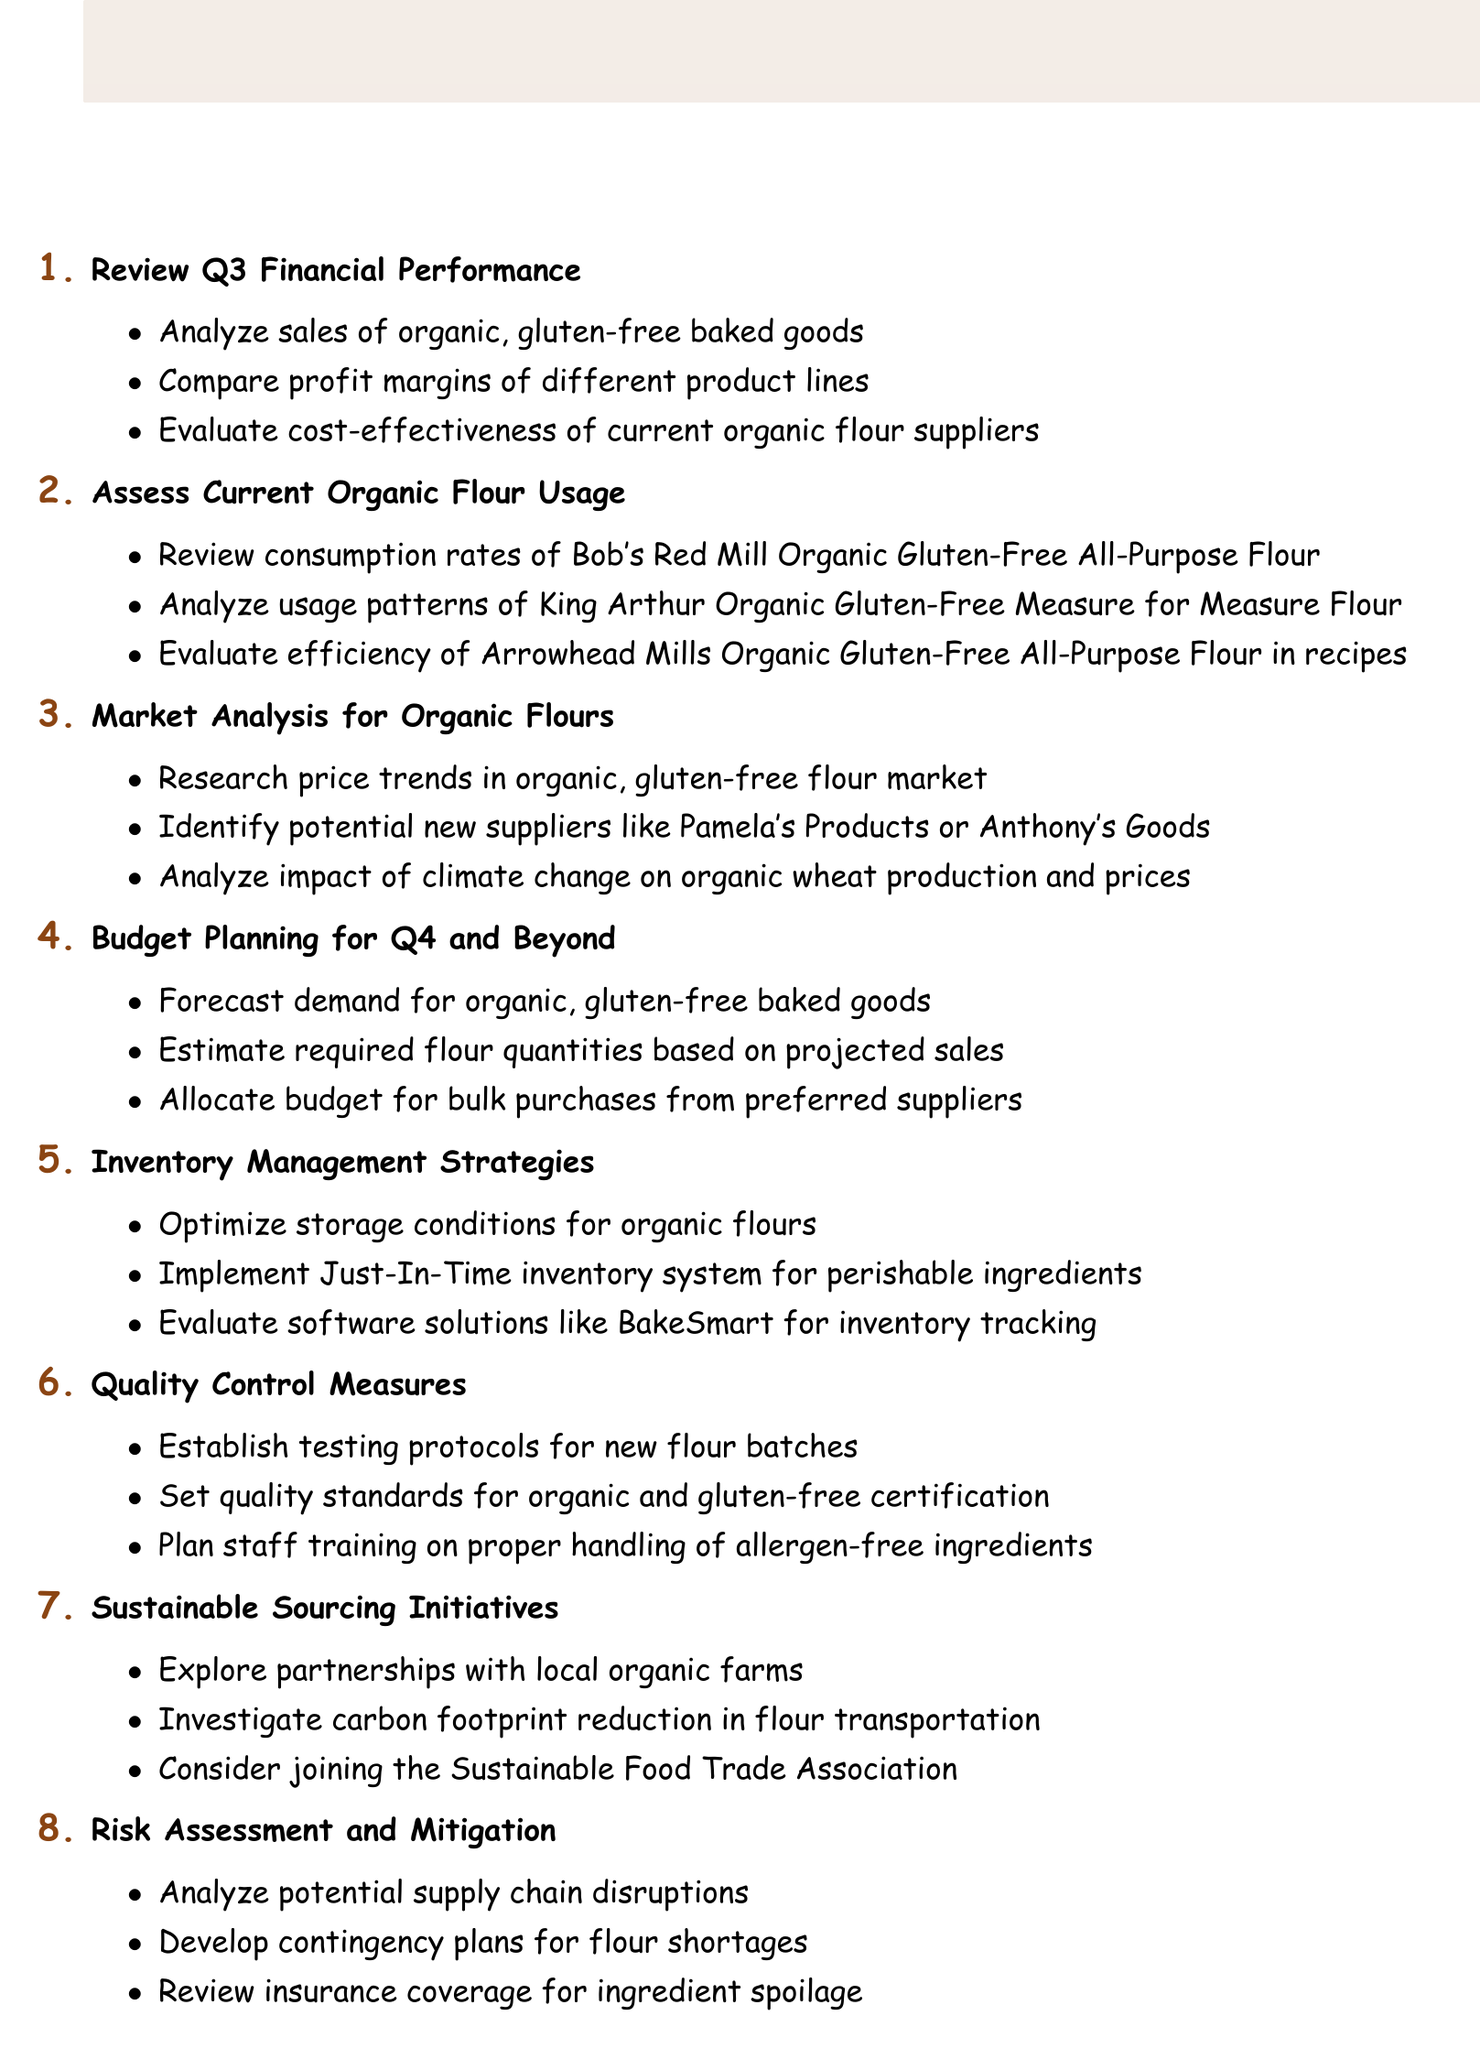what is the title of the first agenda item? The title of the first agenda item is clearly stated in the document under the first bullet point.
Answer: Review Q3 Financial Performance how many sub-items are listed under "Budget Planning for Q4 and Beyond"? The number of sub-items can be quickly counted under the "Budget Planning for Q4 and Beyond" section in the document.
Answer: 3 which brand's organic gluten-free flour consumption rates are reviewed? The document specifies the brand whose consumption rates are reviewed, mentioned under the second agenda item.
Answer: Bob's Red Mill what is one potential new supplier mentioned in the market analysis? The document lists potential new suppliers in the market analysis section, one of which is mentioned specifically.
Answer: Pamela's Products what inventory management strategy is discussed regarding storage conditions? The specific storage strategy under the inventory management strategies can be found clearly in the document.
Answer: Optimize storage conditions for organic flours which alliance is suggested for sustainable sourcing initiatives? The document contains a suggestion for a specific alliance related to sustainable sourcing initiatives.
Answer: Sustainable Food Trade Association what is the focus of the risk assessment in the agenda? The agenda item explicitly mentions the main focus area related to risk.
Answer: Supply chain disruptions what quantity estimation is included in the budget planning? The specific type of estimation mentioned in the "Budget Planning for Q4 and Beyond" section can be referenced.
Answer: Required flour quantities based on projected sales 